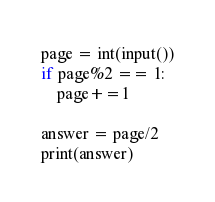Convert code to text. <code><loc_0><loc_0><loc_500><loc_500><_Python_>page = int(input())
if page%2 == 1:
	page+=1

answer = page/2
print(answer)</code> 